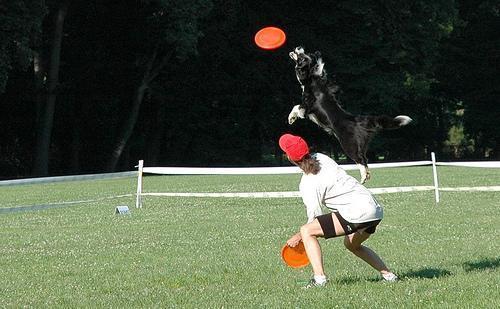How many people are in the photo?
Give a very brief answer. 1. How many bright colored items are in the photo?
Give a very brief answer. 3. How many boats are in the photo?
Give a very brief answer. 0. 